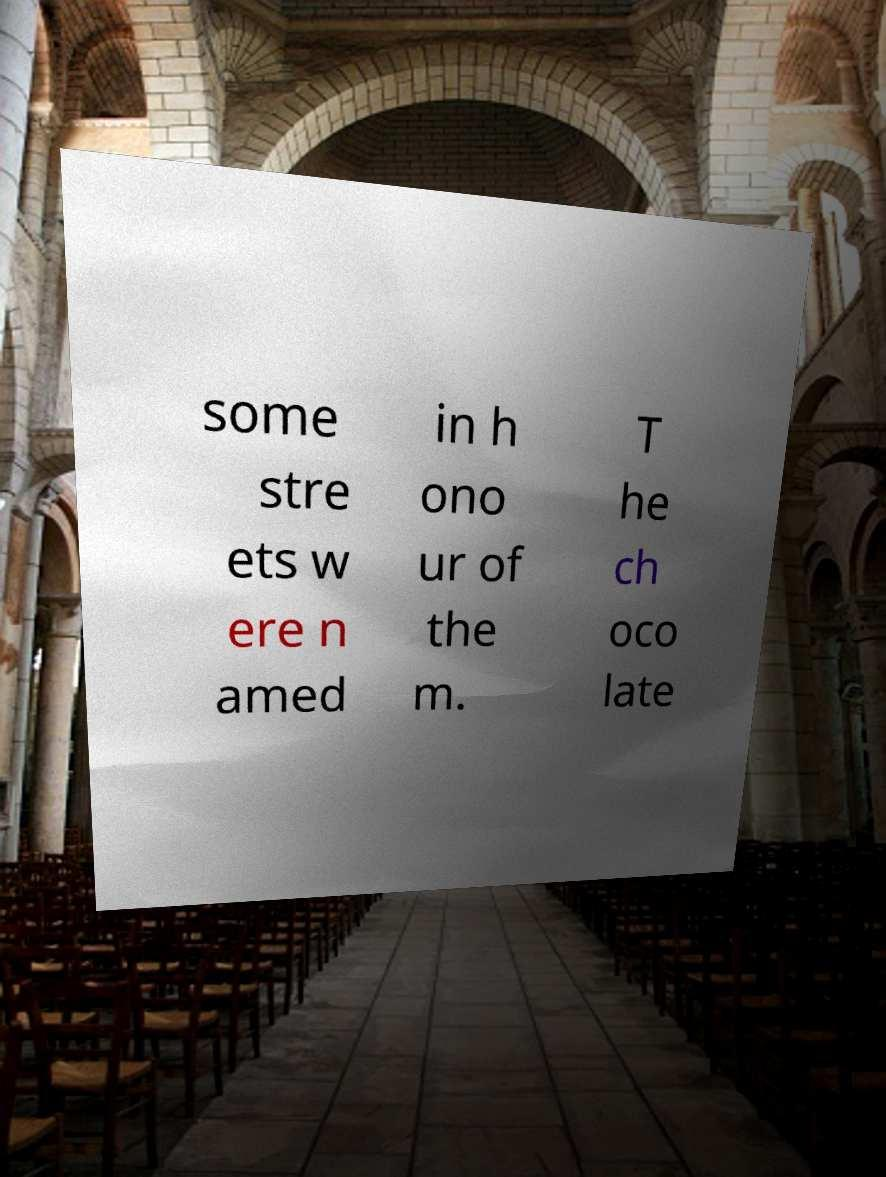I need the written content from this picture converted into text. Can you do that? some stre ets w ere n amed in h ono ur of the m. T he ch oco late 